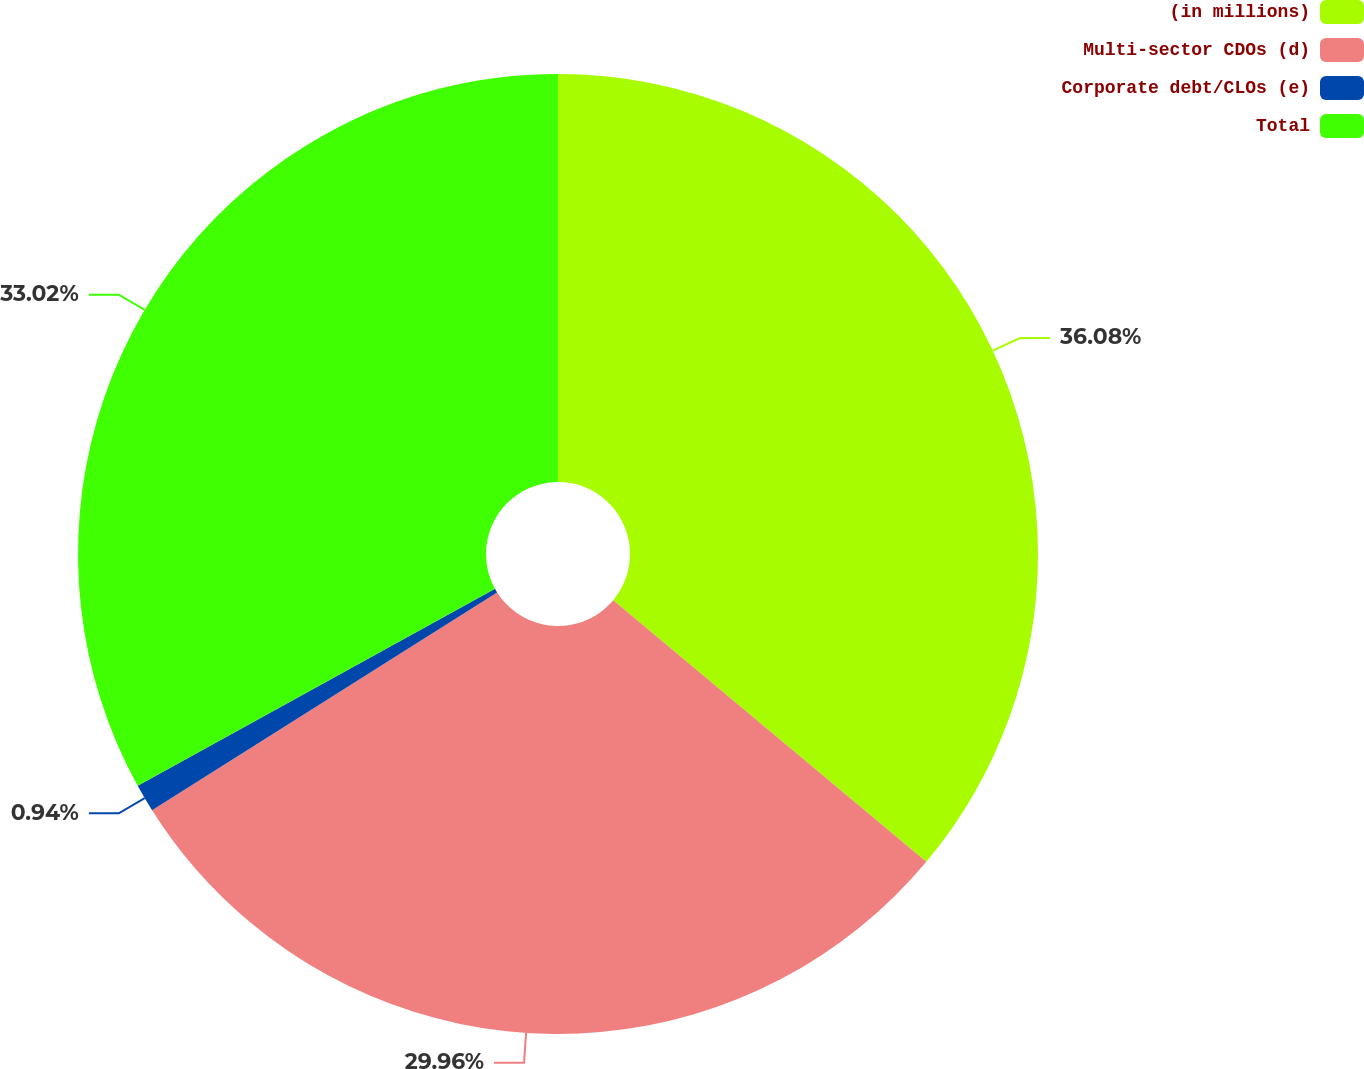Convert chart. <chart><loc_0><loc_0><loc_500><loc_500><pie_chart><fcel>(in millions)<fcel>Multi-sector CDOs (d)<fcel>Corporate debt/CLOs (e)<fcel>Total<nl><fcel>36.08%<fcel>29.96%<fcel>0.94%<fcel>33.02%<nl></chart> 